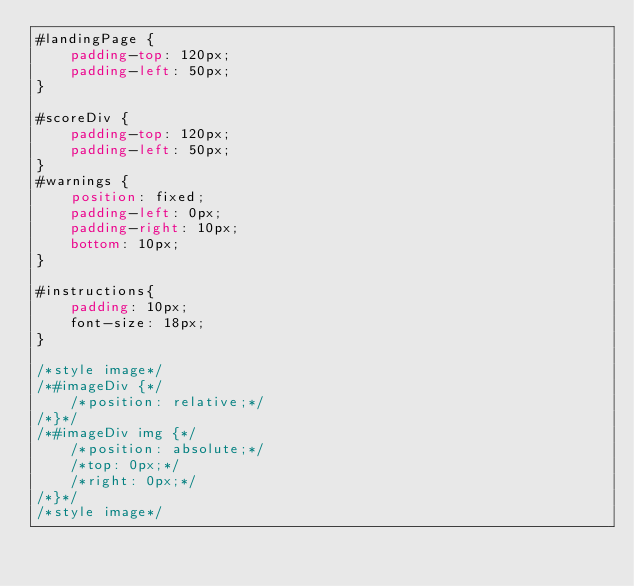<code> <loc_0><loc_0><loc_500><loc_500><_CSS_>#landingPage {
    padding-top: 120px;
    padding-left: 50px;
}

#scoreDiv {
    padding-top: 120px;
    padding-left: 50px;
}
#warnings {
    position: fixed;
    padding-left: 0px;
    padding-right: 10px;
    bottom: 10px;
}

#instructions{
    padding: 10px;
    font-size: 18px;
}

/*style image*/
/*#imageDiv {*/
    /*position: relative;*/
/*}*/
/*#imageDiv img {*/
    /*position: absolute;*/
    /*top: 0px;*/
    /*right: 0px;*/
/*}*/
/*style image*/</code> 